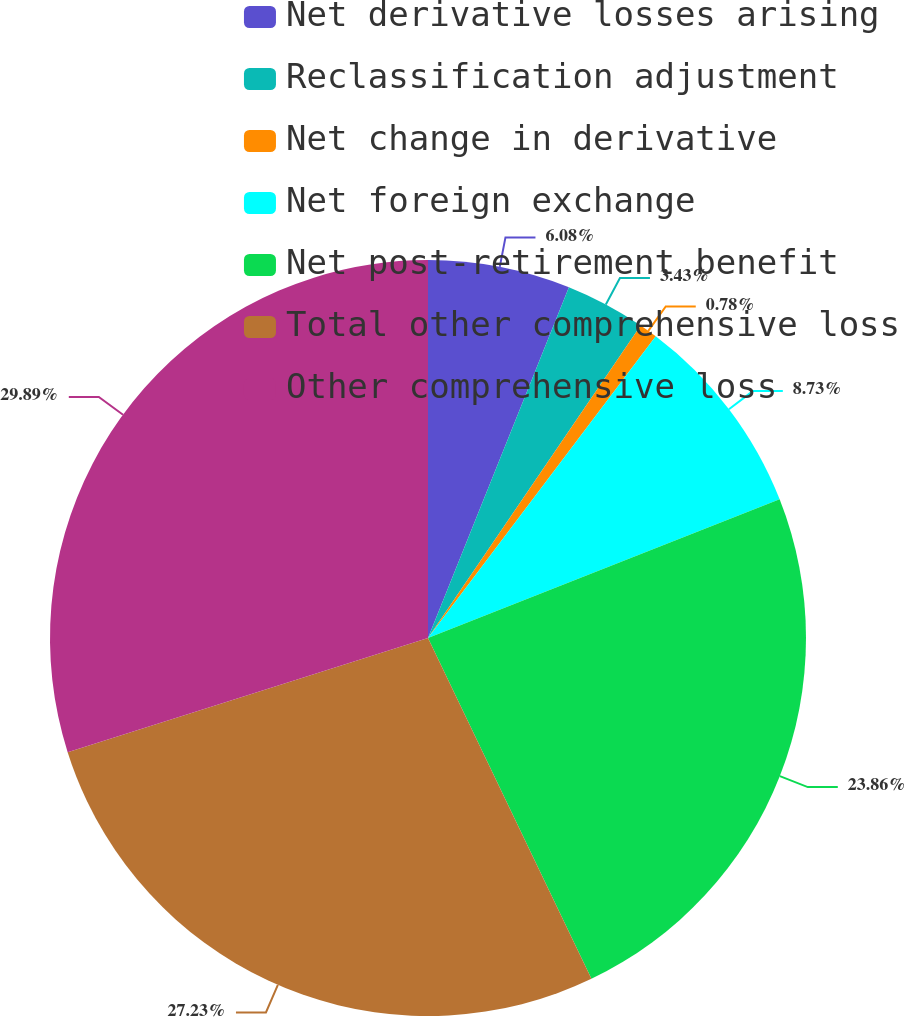<chart> <loc_0><loc_0><loc_500><loc_500><pie_chart><fcel>Net derivative losses arising<fcel>Reclassification adjustment<fcel>Net change in derivative<fcel>Net foreign exchange<fcel>Net post-retirement benefit<fcel>Total other comprehensive loss<fcel>Other comprehensive loss<nl><fcel>6.08%<fcel>3.43%<fcel>0.78%<fcel>8.73%<fcel>23.86%<fcel>27.23%<fcel>29.88%<nl></chart> 